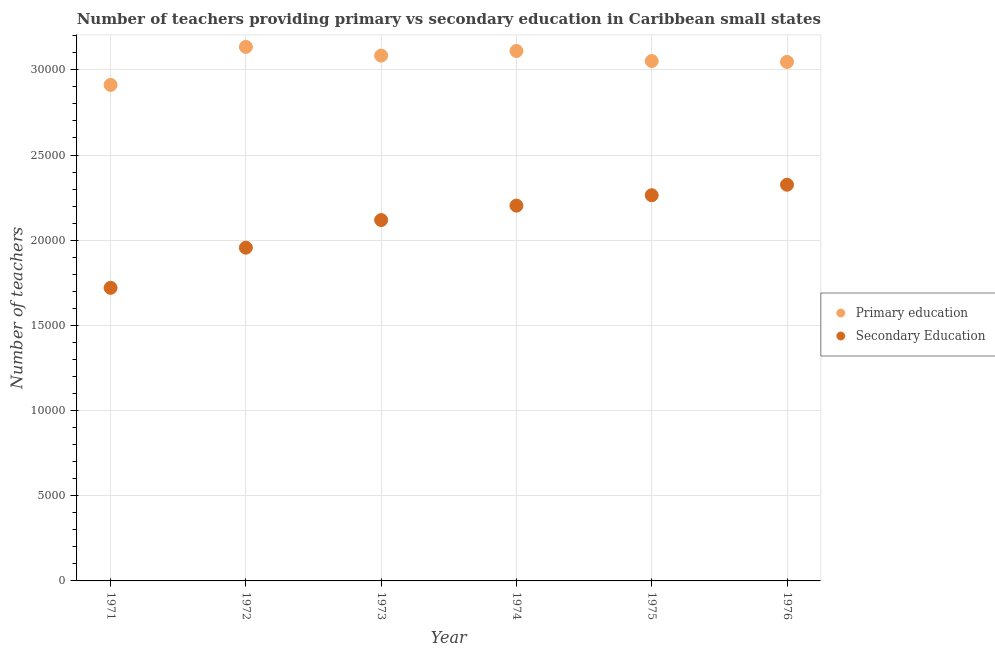How many different coloured dotlines are there?
Provide a succinct answer. 2. Is the number of dotlines equal to the number of legend labels?
Your response must be concise. Yes. What is the number of secondary teachers in 1975?
Your answer should be compact. 2.26e+04. Across all years, what is the maximum number of primary teachers?
Offer a very short reply. 3.13e+04. Across all years, what is the minimum number of primary teachers?
Give a very brief answer. 2.91e+04. In which year was the number of secondary teachers maximum?
Give a very brief answer. 1976. In which year was the number of primary teachers minimum?
Your answer should be very brief. 1971. What is the total number of secondary teachers in the graph?
Provide a succinct answer. 1.26e+05. What is the difference between the number of secondary teachers in 1973 and that in 1974?
Ensure brevity in your answer.  -845.11. What is the difference between the number of secondary teachers in 1973 and the number of primary teachers in 1971?
Ensure brevity in your answer.  -7934. What is the average number of secondary teachers per year?
Ensure brevity in your answer.  2.10e+04. In the year 1974, what is the difference between the number of primary teachers and number of secondary teachers?
Make the answer very short. 9078.04. In how many years, is the number of secondary teachers greater than 17000?
Your answer should be very brief. 6. What is the ratio of the number of primary teachers in 1974 to that in 1975?
Offer a very short reply. 1.02. Is the number of primary teachers in 1974 less than that in 1976?
Keep it short and to the point. No. Is the difference between the number of primary teachers in 1973 and 1976 greater than the difference between the number of secondary teachers in 1973 and 1976?
Keep it short and to the point. Yes. What is the difference between the highest and the second highest number of primary teachers?
Provide a succinct answer. 239.58. What is the difference between the highest and the lowest number of secondary teachers?
Your response must be concise. 6052.23. In how many years, is the number of primary teachers greater than the average number of primary teachers taken over all years?
Your response must be concise. 3. Is the number of primary teachers strictly greater than the number of secondary teachers over the years?
Keep it short and to the point. Yes. Is the number of primary teachers strictly less than the number of secondary teachers over the years?
Keep it short and to the point. No. How many dotlines are there?
Ensure brevity in your answer.  2. What is the difference between two consecutive major ticks on the Y-axis?
Provide a short and direct response. 5000. Does the graph contain grids?
Keep it short and to the point. Yes. Where does the legend appear in the graph?
Your answer should be very brief. Center right. How are the legend labels stacked?
Provide a short and direct response. Vertical. What is the title of the graph?
Give a very brief answer. Number of teachers providing primary vs secondary education in Caribbean small states. Does "Manufacturing industries and construction" appear as one of the legend labels in the graph?
Ensure brevity in your answer.  No. What is the label or title of the X-axis?
Make the answer very short. Year. What is the label or title of the Y-axis?
Your answer should be compact. Number of teachers. What is the Number of teachers of Primary education in 1971?
Provide a succinct answer. 2.91e+04. What is the Number of teachers in Secondary Education in 1971?
Provide a short and direct response. 1.72e+04. What is the Number of teachers of Primary education in 1972?
Your answer should be compact. 3.13e+04. What is the Number of teachers in Secondary Education in 1972?
Keep it short and to the point. 1.96e+04. What is the Number of teachers of Primary education in 1973?
Keep it short and to the point. 3.08e+04. What is the Number of teachers of Secondary Education in 1973?
Give a very brief answer. 2.12e+04. What is the Number of teachers in Primary education in 1974?
Keep it short and to the point. 3.11e+04. What is the Number of teachers of Secondary Education in 1974?
Your answer should be compact. 2.20e+04. What is the Number of teachers in Primary education in 1975?
Your response must be concise. 3.05e+04. What is the Number of teachers in Secondary Education in 1975?
Offer a terse response. 2.26e+04. What is the Number of teachers of Primary education in 1976?
Offer a very short reply. 3.05e+04. What is the Number of teachers in Secondary Education in 1976?
Your answer should be compact. 2.33e+04. Across all years, what is the maximum Number of teachers in Primary education?
Provide a succinct answer. 3.13e+04. Across all years, what is the maximum Number of teachers in Secondary Education?
Offer a very short reply. 2.33e+04. Across all years, what is the minimum Number of teachers in Primary education?
Your answer should be compact. 2.91e+04. Across all years, what is the minimum Number of teachers of Secondary Education?
Make the answer very short. 1.72e+04. What is the total Number of teachers of Primary education in the graph?
Offer a very short reply. 1.83e+05. What is the total Number of teachers of Secondary Education in the graph?
Your response must be concise. 1.26e+05. What is the difference between the Number of teachers in Primary education in 1971 and that in 1972?
Your answer should be very brief. -2228.74. What is the difference between the Number of teachers in Secondary Education in 1971 and that in 1972?
Ensure brevity in your answer.  -2356.54. What is the difference between the Number of teachers in Primary education in 1971 and that in 1973?
Your answer should be very brief. -1719.01. What is the difference between the Number of teachers of Secondary Education in 1971 and that in 1973?
Make the answer very short. -3978.53. What is the difference between the Number of teachers of Primary education in 1971 and that in 1974?
Offer a terse response. -1989.15. What is the difference between the Number of teachers in Secondary Education in 1971 and that in 1974?
Offer a terse response. -4823.64. What is the difference between the Number of teachers of Primary education in 1971 and that in 1975?
Make the answer very short. -1400.51. What is the difference between the Number of teachers in Secondary Education in 1971 and that in 1975?
Keep it short and to the point. -5434.98. What is the difference between the Number of teachers of Primary education in 1971 and that in 1976?
Offer a very short reply. -1348.32. What is the difference between the Number of teachers of Secondary Education in 1971 and that in 1976?
Your response must be concise. -6052.23. What is the difference between the Number of teachers of Primary education in 1972 and that in 1973?
Make the answer very short. 509.73. What is the difference between the Number of teachers in Secondary Education in 1972 and that in 1973?
Your answer should be compact. -1621.99. What is the difference between the Number of teachers in Primary education in 1972 and that in 1974?
Ensure brevity in your answer.  239.58. What is the difference between the Number of teachers in Secondary Education in 1972 and that in 1974?
Offer a terse response. -2467.1. What is the difference between the Number of teachers of Primary education in 1972 and that in 1975?
Offer a very short reply. 828.23. What is the difference between the Number of teachers of Secondary Education in 1972 and that in 1975?
Your response must be concise. -3078.44. What is the difference between the Number of teachers in Primary education in 1972 and that in 1976?
Give a very brief answer. 880.42. What is the difference between the Number of teachers of Secondary Education in 1972 and that in 1976?
Make the answer very short. -3695.69. What is the difference between the Number of teachers in Primary education in 1973 and that in 1974?
Offer a terse response. -270.14. What is the difference between the Number of teachers of Secondary Education in 1973 and that in 1974?
Make the answer very short. -845.11. What is the difference between the Number of teachers in Primary education in 1973 and that in 1975?
Your response must be concise. 318.5. What is the difference between the Number of teachers in Secondary Education in 1973 and that in 1975?
Keep it short and to the point. -1456.45. What is the difference between the Number of teachers of Primary education in 1973 and that in 1976?
Provide a succinct answer. 370.69. What is the difference between the Number of teachers of Secondary Education in 1973 and that in 1976?
Offer a very short reply. -2073.7. What is the difference between the Number of teachers in Primary education in 1974 and that in 1975?
Make the answer very short. 588.64. What is the difference between the Number of teachers in Secondary Education in 1974 and that in 1975?
Ensure brevity in your answer.  -611.34. What is the difference between the Number of teachers in Primary education in 1974 and that in 1976?
Ensure brevity in your answer.  640.83. What is the difference between the Number of teachers of Secondary Education in 1974 and that in 1976?
Provide a succinct answer. -1228.59. What is the difference between the Number of teachers in Primary education in 1975 and that in 1976?
Your answer should be very brief. 52.19. What is the difference between the Number of teachers in Secondary Education in 1975 and that in 1976?
Give a very brief answer. -617.25. What is the difference between the Number of teachers in Primary education in 1971 and the Number of teachers in Secondary Education in 1972?
Provide a short and direct response. 9555.98. What is the difference between the Number of teachers of Primary education in 1971 and the Number of teachers of Secondary Education in 1973?
Make the answer very short. 7934. What is the difference between the Number of teachers in Primary education in 1971 and the Number of teachers in Secondary Education in 1974?
Offer a terse response. 7088.89. What is the difference between the Number of teachers in Primary education in 1971 and the Number of teachers in Secondary Education in 1975?
Ensure brevity in your answer.  6477.55. What is the difference between the Number of teachers in Primary education in 1971 and the Number of teachers in Secondary Education in 1976?
Ensure brevity in your answer.  5860.3. What is the difference between the Number of teachers of Primary education in 1972 and the Number of teachers of Secondary Education in 1973?
Make the answer very short. 1.02e+04. What is the difference between the Number of teachers in Primary education in 1972 and the Number of teachers in Secondary Education in 1974?
Your response must be concise. 9317.62. What is the difference between the Number of teachers in Primary education in 1972 and the Number of teachers in Secondary Education in 1975?
Your answer should be very brief. 8706.29. What is the difference between the Number of teachers of Primary education in 1972 and the Number of teachers of Secondary Education in 1976?
Your response must be concise. 8089.04. What is the difference between the Number of teachers of Primary education in 1973 and the Number of teachers of Secondary Education in 1974?
Make the answer very short. 8807.9. What is the difference between the Number of teachers in Primary education in 1973 and the Number of teachers in Secondary Education in 1975?
Ensure brevity in your answer.  8196.56. What is the difference between the Number of teachers of Primary education in 1973 and the Number of teachers of Secondary Education in 1976?
Ensure brevity in your answer.  7579.31. What is the difference between the Number of teachers in Primary education in 1974 and the Number of teachers in Secondary Education in 1975?
Give a very brief answer. 8466.7. What is the difference between the Number of teachers of Primary education in 1974 and the Number of teachers of Secondary Education in 1976?
Give a very brief answer. 7849.45. What is the difference between the Number of teachers of Primary education in 1975 and the Number of teachers of Secondary Education in 1976?
Offer a terse response. 7260.81. What is the average Number of teachers of Primary education per year?
Give a very brief answer. 3.06e+04. What is the average Number of teachers in Secondary Education per year?
Your response must be concise. 2.10e+04. In the year 1971, what is the difference between the Number of teachers in Primary education and Number of teachers in Secondary Education?
Keep it short and to the point. 1.19e+04. In the year 1972, what is the difference between the Number of teachers of Primary education and Number of teachers of Secondary Education?
Ensure brevity in your answer.  1.18e+04. In the year 1973, what is the difference between the Number of teachers in Primary education and Number of teachers in Secondary Education?
Offer a terse response. 9653.01. In the year 1974, what is the difference between the Number of teachers in Primary education and Number of teachers in Secondary Education?
Ensure brevity in your answer.  9078.04. In the year 1975, what is the difference between the Number of teachers in Primary education and Number of teachers in Secondary Education?
Your answer should be compact. 7878.06. In the year 1976, what is the difference between the Number of teachers in Primary education and Number of teachers in Secondary Education?
Your response must be concise. 7208.62. What is the ratio of the Number of teachers in Primary education in 1971 to that in 1972?
Provide a short and direct response. 0.93. What is the ratio of the Number of teachers in Secondary Education in 1971 to that in 1972?
Your answer should be very brief. 0.88. What is the ratio of the Number of teachers in Primary education in 1971 to that in 1973?
Your answer should be very brief. 0.94. What is the ratio of the Number of teachers in Secondary Education in 1971 to that in 1973?
Offer a terse response. 0.81. What is the ratio of the Number of teachers of Primary education in 1971 to that in 1974?
Offer a very short reply. 0.94. What is the ratio of the Number of teachers of Secondary Education in 1971 to that in 1974?
Offer a very short reply. 0.78. What is the ratio of the Number of teachers in Primary education in 1971 to that in 1975?
Your answer should be very brief. 0.95. What is the ratio of the Number of teachers in Secondary Education in 1971 to that in 1975?
Your response must be concise. 0.76. What is the ratio of the Number of teachers of Primary education in 1971 to that in 1976?
Keep it short and to the point. 0.96. What is the ratio of the Number of teachers of Secondary Education in 1971 to that in 1976?
Provide a succinct answer. 0.74. What is the ratio of the Number of teachers of Primary education in 1972 to that in 1973?
Give a very brief answer. 1.02. What is the ratio of the Number of teachers in Secondary Education in 1972 to that in 1973?
Keep it short and to the point. 0.92. What is the ratio of the Number of teachers in Primary education in 1972 to that in 1974?
Ensure brevity in your answer.  1.01. What is the ratio of the Number of teachers of Secondary Education in 1972 to that in 1974?
Give a very brief answer. 0.89. What is the ratio of the Number of teachers of Primary education in 1972 to that in 1975?
Offer a terse response. 1.03. What is the ratio of the Number of teachers of Secondary Education in 1972 to that in 1975?
Provide a short and direct response. 0.86. What is the ratio of the Number of teachers in Primary education in 1972 to that in 1976?
Give a very brief answer. 1.03. What is the ratio of the Number of teachers of Secondary Education in 1972 to that in 1976?
Provide a short and direct response. 0.84. What is the ratio of the Number of teachers of Primary education in 1973 to that in 1974?
Keep it short and to the point. 0.99. What is the ratio of the Number of teachers in Secondary Education in 1973 to that in 1974?
Provide a succinct answer. 0.96. What is the ratio of the Number of teachers of Primary education in 1973 to that in 1975?
Give a very brief answer. 1.01. What is the ratio of the Number of teachers in Secondary Education in 1973 to that in 1975?
Keep it short and to the point. 0.94. What is the ratio of the Number of teachers in Primary education in 1973 to that in 1976?
Offer a terse response. 1.01. What is the ratio of the Number of teachers of Secondary Education in 1973 to that in 1976?
Your response must be concise. 0.91. What is the ratio of the Number of teachers in Primary education in 1974 to that in 1975?
Provide a short and direct response. 1.02. What is the ratio of the Number of teachers in Primary education in 1974 to that in 1976?
Keep it short and to the point. 1.02. What is the ratio of the Number of teachers in Secondary Education in 1974 to that in 1976?
Offer a terse response. 0.95. What is the ratio of the Number of teachers of Primary education in 1975 to that in 1976?
Offer a terse response. 1. What is the ratio of the Number of teachers in Secondary Education in 1975 to that in 1976?
Provide a short and direct response. 0.97. What is the difference between the highest and the second highest Number of teachers in Primary education?
Keep it short and to the point. 239.58. What is the difference between the highest and the second highest Number of teachers of Secondary Education?
Ensure brevity in your answer.  617.25. What is the difference between the highest and the lowest Number of teachers in Primary education?
Your answer should be very brief. 2228.74. What is the difference between the highest and the lowest Number of teachers of Secondary Education?
Give a very brief answer. 6052.23. 